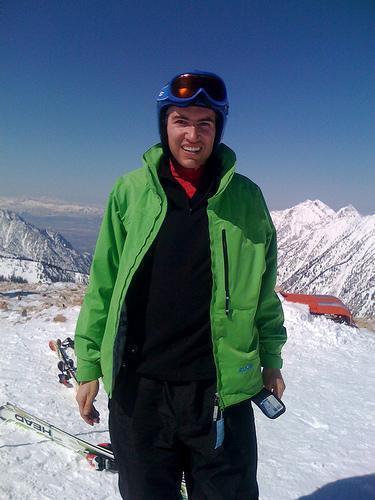How many pairs of goggles is the man wearing?
Give a very brief answer. 1. 